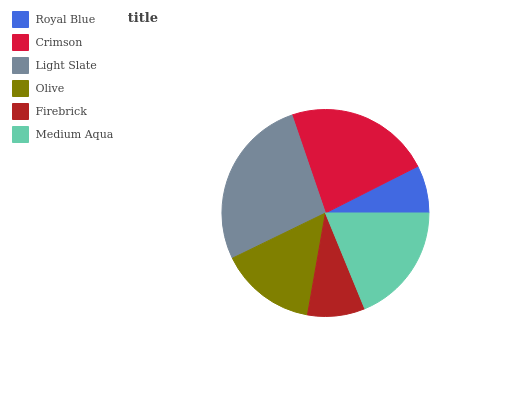Is Royal Blue the minimum?
Answer yes or no. Yes. Is Light Slate the maximum?
Answer yes or no. Yes. Is Crimson the minimum?
Answer yes or no. No. Is Crimson the maximum?
Answer yes or no. No. Is Crimson greater than Royal Blue?
Answer yes or no. Yes. Is Royal Blue less than Crimson?
Answer yes or no. Yes. Is Royal Blue greater than Crimson?
Answer yes or no. No. Is Crimson less than Royal Blue?
Answer yes or no. No. Is Medium Aqua the high median?
Answer yes or no. Yes. Is Olive the low median?
Answer yes or no. Yes. Is Royal Blue the high median?
Answer yes or no. No. Is Medium Aqua the low median?
Answer yes or no. No. 